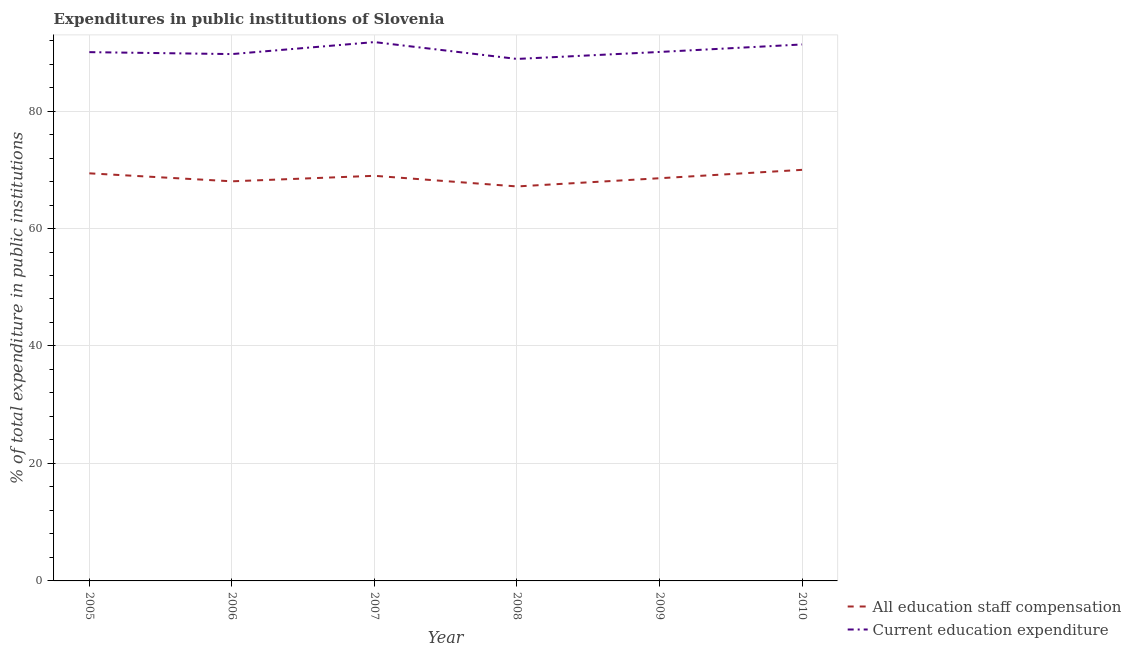Does the line corresponding to expenditure in education intersect with the line corresponding to expenditure in staff compensation?
Make the answer very short. No. What is the expenditure in staff compensation in 2006?
Provide a short and direct response. 68.04. Across all years, what is the maximum expenditure in education?
Your answer should be very brief. 91.74. Across all years, what is the minimum expenditure in staff compensation?
Your answer should be compact. 67.16. In which year was the expenditure in staff compensation maximum?
Your answer should be very brief. 2010. In which year was the expenditure in education minimum?
Keep it short and to the point. 2008. What is the total expenditure in education in the graph?
Ensure brevity in your answer.  541.73. What is the difference between the expenditure in staff compensation in 2006 and that in 2009?
Your answer should be very brief. -0.52. What is the difference between the expenditure in staff compensation in 2005 and the expenditure in education in 2009?
Your answer should be compact. -20.66. What is the average expenditure in education per year?
Offer a terse response. 90.29. In the year 2009, what is the difference between the expenditure in staff compensation and expenditure in education?
Provide a succinct answer. -21.5. In how many years, is the expenditure in education greater than 40 %?
Keep it short and to the point. 6. What is the ratio of the expenditure in staff compensation in 2005 to that in 2007?
Offer a very short reply. 1.01. Is the expenditure in education in 2005 less than that in 2009?
Provide a succinct answer. Yes. Is the difference between the expenditure in staff compensation in 2009 and 2010 greater than the difference between the expenditure in education in 2009 and 2010?
Make the answer very short. No. What is the difference between the highest and the second highest expenditure in education?
Make the answer very short. 0.4. What is the difference between the highest and the lowest expenditure in staff compensation?
Offer a terse response. 2.82. In how many years, is the expenditure in staff compensation greater than the average expenditure in staff compensation taken over all years?
Your answer should be compact. 3. Does the expenditure in education monotonically increase over the years?
Offer a very short reply. No. Is the expenditure in staff compensation strictly greater than the expenditure in education over the years?
Give a very brief answer. No. Is the expenditure in education strictly less than the expenditure in staff compensation over the years?
Offer a terse response. No. Does the graph contain grids?
Your answer should be compact. Yes. Where does the legend appear in the graph?
Offer a terse response. Bottom right. How are the legend labels stacked?
Offer a terse response. Vertical. What is the title of the graph?
Offer a very short reply. Expenditures in public institutions of Slovenia. Does "Crop" appear as one of the legend labels in the graph?
Keep it short and to the point. No. What is the label or title of the Y-axis?
Provide a short and direct response. % of total expenditure in public institutions. What is the % of total expenditure in public institutions of All education staff compensation in 2005?
Give a very brief answer. 69.39. What is the % of total expenditure in public institutions of Current education expenditure in 2005?
Provide a short and direct response. 90.03. What is the % of total expenditure in public institutions of All education staff compensation in 2006?
Keep it short and to the point. 68.04. What is the % of total expenditure in public institutions of Current education expenditure in 2006?
Your answer should be very brief. 89.7. What is the % of total expenditure in public institutions of All education staff compensation in 2007?
Offer a very short reply. 68.97. What is the % of total expenditure in public institutions in Current education expenditure in 2007?
Offer a very short reply. 91.74. What is the % of total expenditure in public institutions in All education staff compensation in 2008?
Keep it short and to the point. 67.16. What is the % of total expenditure in public institutions in Current education expenditure in 2008?
Your response must be concise. 88.87. What is the % of total expenditure in public institutions in All education staff compensation in 2009?
Provide a succinct answer. 68.56. What is the % of total expenditure in public institutions of Current education expenditure in 2009?
Provide a succinct answer. 90.06. What is the % of total expenditure in public institutions in All education staff compensation in 2010?
Your response must be concise. 69.99. What is the % of total expenditure in public institutions in Current education expenditure in 2010?
Offer a terse response. 91.34. Across all years, what is the maximum % of total expenditure in public institutions of All education staff compensation?
Provide a succinct answer. 69.99. Across all years, what is the maximum % of total expenditure in public institutions in Current education expenditure?
Your answer should be very brief. 91.74. Across all years, what is the minimum % of total expenditure in public institutions in All education staff compensation?
Provide a short and direct response. 67.16. Across all years, what is the minimum % of total expenditure in public institutions in Current education expenditure?
Your response must be concise. 88.87. What is the total % of total expenditure in public institutions of All education staff compensation in the graph?
Ensure brevity in your answer.  412.12. What is the total % of total expenditure in public institutions of Current education expenditure in the graph?
Offer a very short reply. 541.73. What is the difference between the % of total expenditure in public institutions of All education staff compensation in 2005 and that in 2006?
Your answer should be very brief. 1.36. What is the difference between the % of total expenditure in public institutions in Current education expenditure in 2005 and that in 2006?
Give a very brief answer. 0.33. What is the difference between the % of total expenditure in public institutions of All education staff compensation in 2005 and that in 2007?
Your response must be concise. 0.42. What is the difference between the % of total expenditure in public institutions in Current education expenditure in 2005 and that in 2007?
Make the answer very short. -1.71. What is the difference between the % of total expenditure in public institutions of All education staff compensation in 2005 and that in 2008?
Make the answer very short. 2.23. What is the difference between the % of total expenditure in public institutions of Current education expenditure in 2005 and that in 2008?
Give a very brief answer. 1.16. What is the difference between the % of total expenditure in public institutions in All education staff compensation in 2005 and that in 2009?
Make the answer very short. 0.83. What is the difference between the % of total expenditure in public institutions of Current education expenditure in 2005 and that in 2009?
Provide a short and direct response. -0.03. What is the difference between the % of total expenditure in public institutions of All education staff compensation in 2005 and that in 2010?
Offer a very short reply. -0.59. What is the difference between the % of total expenditure in public institutions of Current education expenditure in 2005 and that in 2010?
Make the answer very short. -1.31. What is the difference between the % of total expenditure in public institutions of All education staff compensation in 2006 and that in 2007?
Your answer should be very brief. -0.94. What is the difference between the % of total expenditure in public institutions of Current education expenditure in 2006 and that in 2007?
Give a very brief answer. -2.04. What is the difference between the % of total expenditure in public institutions in All education staff compensation in 2006 and that in 2008?
Your response must be concise. 0.87. What is the difference between the % of total expenditure in public institutions of Current education expenditure in 2006 and that in 2008?
Give a very brief answer. 0.83. What is the difference between the % of total expenditure in public institutions of All education staff compensation in 2006 and that in 2009?
Offer a terse response. -0.52. What is the difference between the % of total expenditure in public institutions in Current education expenditure in 2006 and that in 2009?
Keep it short and to the point. -0.36. What is the difference between the % of total expenditure in public institutions of All education staff compensation in 2006 and that in 2010?
Ensure brevity in your answer.  -1.95. What is the difference between the % of total expenditure in public institutions in Current education expenditure in 2006 and that in 2010?
Keep it short and to the point. -1.64. What is the difference between the % of total expenditure in public institutions in All education staff compensation in 2007 and that in 2008?
Offer a very short reply. 1.81. What is the difference between the % of total expenditure in public institutions of Current education expenditure in 2007 and that in 2008?
Make the answer very short. 2.87. What is the difference between the % of total expenditure in public institutions of All education staff compensation in 2007 and that in 2009?
Your answer should be very brief. 0.41. What is the difference between the % of total expenditure in public institutions of Current education expenditure in 2007 and that in 2009?
Make the answer very short. 1.68. What is the difference between the % of total expenditure in public institutions in All education staff compensation in 2007 and that in 2010?
Make the answer very short. -1.01. What is the difference between the % of total expenditure in public institutions in Current education expenditure in 2007 and that in 2010?
Keep it short and to the point. 0.4. What is the difference between the % of total expenditure in public institutions of All education staff compensation in 2008 and that in 2009?
Your response must be concise. -1.4. What is the difference between the % of total expenditure in public institutions of Current education expenditure in 2008 and that in 2009?
Make the answer very short. -1.19. What is the difference between the % of total expenditure in public institutions in All education staff compensation in 2008 and that in 2010?
Provide a succinct answer. -2.82. What is the difference between the % of total expenditure in public institutions in Current education expenditure in 2008 and that in 2010?
Provide a succinct answer. -2.46. What is the difference between the % of total expenditure in public institutions in All education staff compensation in 2009 and that in 2010?
Provide a succinct answer. -1.43. What is the difference between the % of total expenditure in public institutions of Current education expenditure in 2009 and that in 2010?
Offer a terse response. -1.28. What is the difference between the % of total expenditure in public institutions of All education staff compensation in 2005 and the % of total expenditure in public institutions of Current education expenditure in 2006?
Provide a short and direct response. -20.3. What is the difference between the % of total expenditure in public institutions of All education staff compensation in 2005 and the % of total expenditure in public institutions of Current education expenditure in 2007?
Your answer should be very brief. -22.34. What is the difference between the % of total expenditure in public institutions in All education staff compensation in 2005 and the % of total expenditure in public institutions in Current education expenditure in 2008?
Your answer should be very brief. -19.48. What is the difference between the % of total expenditure in public institutions of All education staff compensation in 2005 and the % of total expenditure in public institutions of Current education expenditure in 2009?
Keep it short and to the point. -20.66. What is the difference between the % of total expenditure in public institutions of All education staff compensation in 2005 and the % of total expenditure in public institutions of Current education expenditure in 2010?
Ensure brevity in your answer.  -21.94. What is the difference between the % of total expenditure in public institutions of All education staff compensation in 2006 and the % of total expenditure in public institutions of Current education expenditure in 2007?
Your response must be concise. -23.7. What is the difference between the % of total expenditure in public institutions in All education staff compensation in 2006 and the % of total expenditure in public institutions in Current education expenditure in 2008?
Provide a short and direct response. -20.84. What is the difference between the % of total expenditure in public institutions in All education staff compensation in 2006 and the % of total expenditure in public institutions in Current education expenditure in 2009?
Give a very brief answer. -22.02. What is the difference between the % of total expenditure in public institutions of All education staff compensation in 2006 and the % of total expenditure in public institutions of Current education expenditure in 2010?
Ensure brevity in your answer.  -23.3. What is the difference between the % of total expenditure in public institutions in All education staff compensation in 2007 and the % of total expenditure in public institutions in Current education expenditure in 2008?
Ensure brevity in your answer.  -19.9. What is the difference between the % of total expenditure in public institutions in All education staff compensation in 2007 and the % of total expenditure in public institutions in Current education expenditure in 2009?
Make the answer very short. -21.08. What is the difference between the % of total expenditure in public institutions of All education staff compensation in 2007 and the % of total expenditure in public institutions of Current education expenditure in 2010?
Make the answer very short. -22.36. What is the difference between the % of total expenditure in public institutions of All education staff compensation in 2008 and the % of total expenditure in public institutions of Current education expenditure in 2009?
Make the answer very short. -22.9. What is the difference between the % of total expenditure in public institutions of All education staff compensation in 2008 and the % of total expenditure in public institutions of Current education expenditure in 2010?
Your response must be concise. -24.17. What is the difference between the % of total expenditure in public institutions in All education staff compensation in 2009 and the % of total expenditure in public institutions in Current education expenditure in 2010?
Provide a succinct answer. -22.78. What is the average % of total expenditure in public institutions in All education staff compensation per year?
Keep it short and to the point. 68.69. What is the average % of total expenditure in public institutions of Current education expenditure per year?
Your answer should be compact. 90.29. In the year 2005, what is the difference between the % of total expenditure in public institutions in All education staff compensation and % of total expenditure in public institutions in Current education expenditure?
Offer a terse response. -20.63. In the year 2006, what is the difference between the % of total expenditure in public institutions of All education staff compensation and % of total expenditure in public institutions of Current education expenditure?
Your answer should be compact. -21.66. In the year 2007, what is the difference between the % of total expenditure in public institutions in All education staff compensation and % of total expenditure in public institutions in Current education expenditure?
Provide a short and direct response. -22.76. In the year 2008, what is the difference between the % of total expenditure in public institutions of All education staff compensation and % of total expenditure in public institutions of Current education expenditure?
Provide a succinct answer. -21.71. In the year 2009, what is the difference between the % of total expenditure in public institutions of All education staff compensation and % of total expenditure in public institutions of Current education expenditure?
Offer a very short reply. -21.5. In the year 2010, what is the difference between the % of total expenditure in public institutions in All education staff compensation and % of total expenditure in public institutions in Current education expenditure?
Offer a terse response. -21.35. What is the ratio of the % of total expenditure in public institutions of All education staff compensation in 2005 to that in 2006?
Offer a terse response. 1.02. What is the ratio of the % of total expenditure in public institutions in All education staff compensation in 2005 to that in 2007?
Make the answer very short. 1.01. What is the ratio of the % of total expenditure in public institutions in Current education expenditure in 2005 to that in 2007?
Offer a very short reply. 0.98. What is the ratio of the % of total expenditure in public institutions of All education staff compensation in 2005 to that in 2008?
Ensure brevity in your answer.  1.03. What is the ratio of the % of total expenditure in public institutions of Current education expenditure in 2005 to that in 2008?
Offer a very short reply. 1.01. What is the ratio of the % of total expenditure in public institutions in All education staff compensation in 2005 to that in 2009?
Your answer should be compact. 1.01. What is the ratio of the % of total expenditure in public institutions in All education staff compensation in 2005 to that in 2010?
Your response must be concise. 0.99. What is the ratio of the % of total expenditure in public institutions in Current education expenditure in 2005 to that in 2010?
Your response must be concise. 0.99. What is the ratio of the % of total expenditure in public institutions of All education staff compensation in 2006 to that in 2007?
Make the answer very short. 0.99. What is the ratio of the % of total expenditure in public institutions in Current education expenditure in 2006 to that in 2007?
Make the answer very short. 0.98. What is the ratio of the % of total expenditure in public institutions of Current education expenditure in 2006 to that in 2008?
Make the answer very short. 1.01. What is the ratio of the % of total expenditure in public institutions in All education staff compensation in 2006 to that in 2009?
Offer a very short reply. 0.99. What is the ratio of the % of total expenditure in public institutions in All education staff compensation in 2006 to that in 2010?
Offer a very short reply. 0.97. What is the ratio of the % of total expenditure in public institutions of Current education expenditure in 2006 to that in 2010?
Keep it short and to the point. 0.98. What is the ratio of the % of total expenditure in public institutions in All education staff compensation in 2007 to that in 2008?
Make the answer very short. 1.03. What is the ratio of the % of total expenditure in public institutions in Current education expenditure in 2007 to that in 2008?
Make the answer very short. 1.03. What is the ratio of the % of total expenditure in public institutions in Current education expenditure in 2007 to that in 2009?
Provide a succinct answer. 1.02. What is the ratio of the % of total expenditure in public institutions in All education staff compensation in 2007 to that in 2010?
Your response must be concise. 0.99. What is the ratio of the % of total expenditure in public institutions in All education staff compensation in 2008 to that in 2009?
Offer a very short reply. 0.98. What is the ratio of the % of total expenditure in public institutions of Current education expenditure in 2008 to that in 2009?
Your response must be concise. 0.99. What is the ratio of the % of total expenditure in public institutions in All education staff compensation in 2008 to that in 2010?
Ensure brevity in your answer.  0.96. What is the ratio of the % of total expenditure in public institutions in All education staff compensation in 2009 to that in 2010?
Ensure brevity in your answer.  0.98. What is the ratio of the % of total expenditure in public institutions in Current education expenditure in 2009 to that in 2010?
Provide a short and direct response. 0.99. What is the difference between the highest and the second highest % of total expenditure in public institutions in All education staff compensation?
Your answer should be compact. 0.59. What is the difference between the highest and the second highest % of total expenditure in public institutions in Current education expenditure?
Give a very brief answer. 0.4. What is the difference between the highest and the lowest % of total expenditure in public institutions in All education staff compensation?
Make the answer very short. 2.82. What is the difference between the highest and the lowest % of total expenditure in public institutions in Current education expenditure?
Offer a terse response. 2.87. 